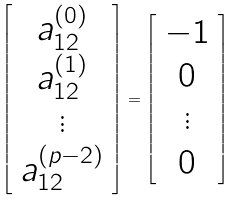Convert formula to latex. <formula><loc_0><loc_0><loc_500><loc_500>\left [ \begin{array} { c } a _ { 1 2 } ^ { ( 0 ) } \\ a _ { 1 2 } ^ { ( 1 ) } \\ \vdots \\ a _ { 1 2 } ^ { ( p - 2 ) } \end{array} \right ] = \left [ \begin{array} { c } - 1 \\ 0 \\ \vdots \\ 0 \end{array} \right ]</formula> 